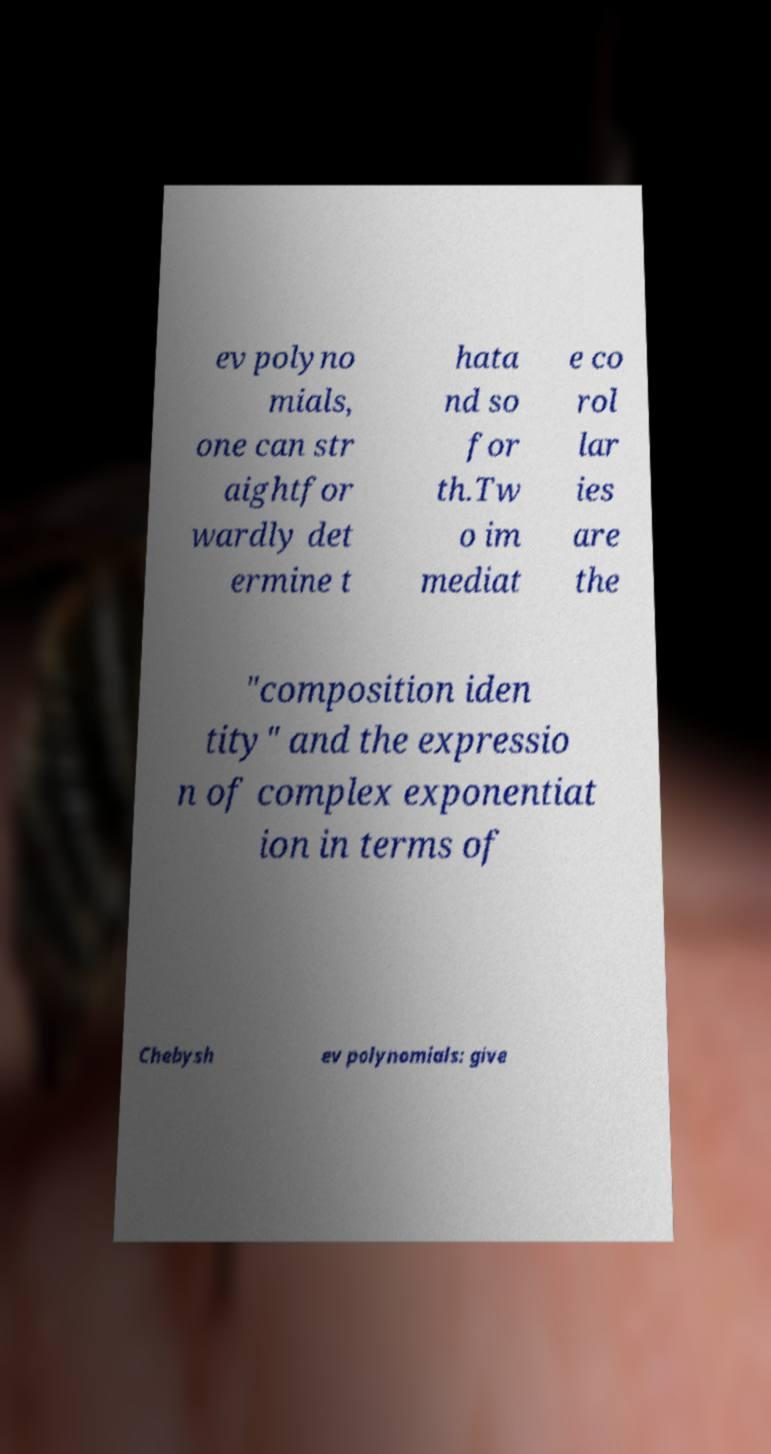Could you extract and type out the text from this image? ev polyno mials, one can str aightfor wardly det ermine t hata nd so for th.Tw o im mediat e co rol lar ies are the "composition iden tity" and the expressio n of complex exponentiat ion in terms of Chebysh ev polynomials: give 